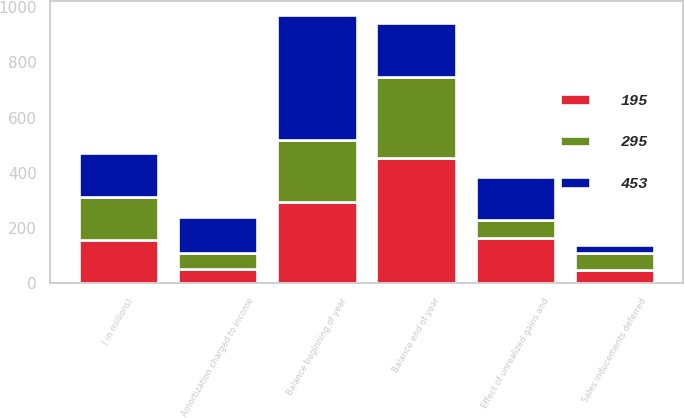Convert chart to OTSL. <chart><loc_0><loc_0><loc_500><loc_500><stacked_bar_chart><ecel><fcel>( in millions)<fcel>Balance beginning of year<fcel>Sales inducements deferred<fcel>Amortization charged to income<fcel>Effect of unrealized gains and<fcel>Balance end of year<nl><fcel>453<fcel>157<fcel>453<fcel>28<fcel>129<fcel>157<fcel>195<nl><fcel>195<fcel>157<fcel>295<fcel>47<fcel>53<fcel>164<fcel>453<nl><fcel>295<fcel>157<fcel>225<fcel>64<fcel>57<fcel>65<fcel>295<nl></chart> 